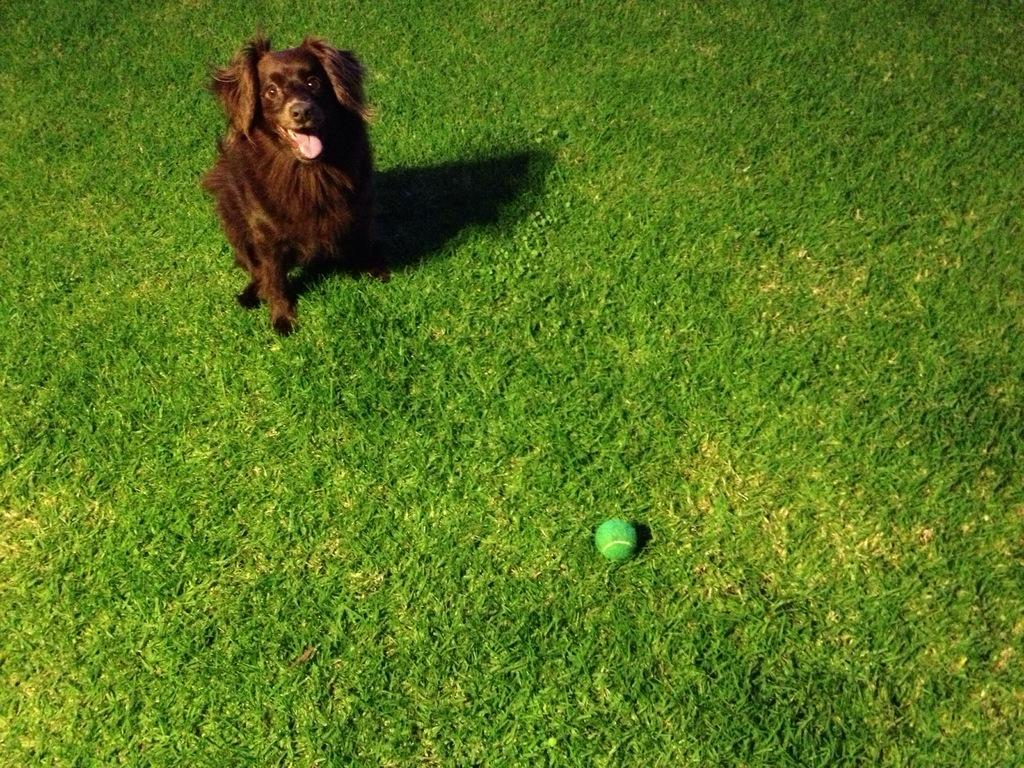What type of animal is present in the image? There is a dog in the image. What object is also visible in the image? There is a ball in the image. Where are the dog and ball located? The dog and ball are on the grass. What type of fruit is the dog holding in the image? There is no fruit, including a banana, present in the image. 